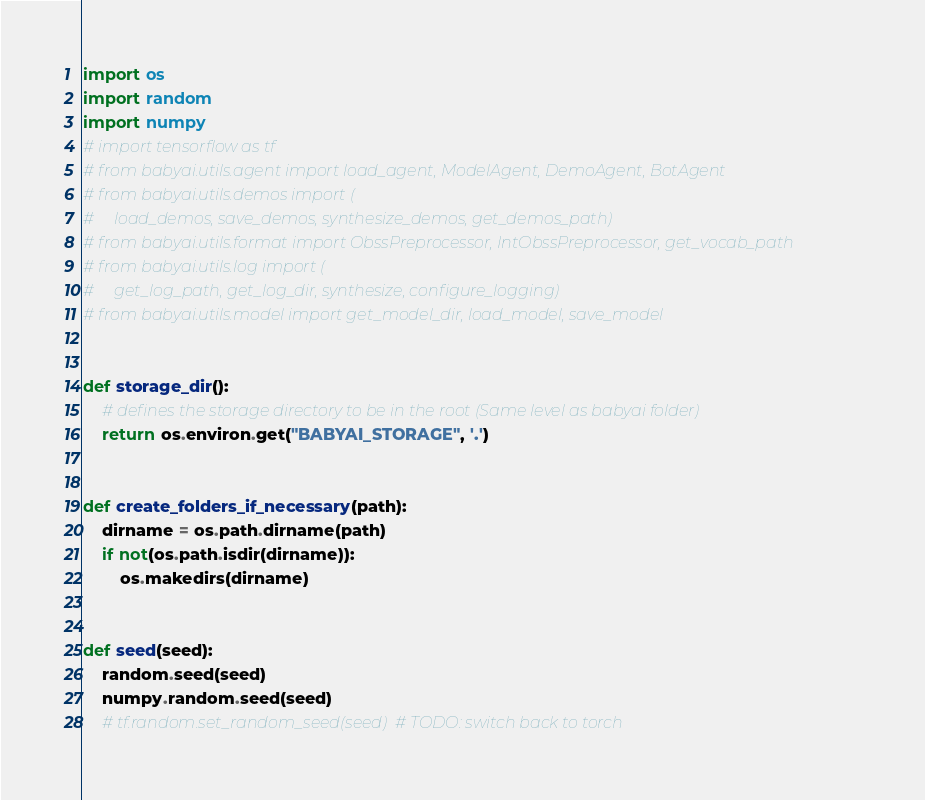<code> <loc_0><loc_0><loc_500><loc_500><_Python_>import os
import random
import numpy
# import tensorflow as tf
# from babyai.utils.agent import load_agent, ModelAgent, DemoAgent, BotAgent
# from babyai.utils.demos import (
#     load_demos, save_demos, synthesize_demos, get_demos_path)
# from babyai.utils.format import ObssPreprocessor, IntObssPreprocessor, get_vocab_path
# from babyai.utils.log import (
#     get_log_path, get_log_dir, synthesize, configure_logging)
# from babyai.utils.model import get_model_dir, load_model, save_model


def storage_dir():
    # defines the storage directory to be in the root (Same level as babyai folder)
    return os.environ.get("BABYAI_STORAGE", '.')


def create_folders_if_necessary(path):
    dirname = os.path.dirname(path)
    if not(os.path.isdir(dirname)):
        os.makedirs(dirname)


def seed(seed):
    random.seed(seed)
    numpy.random.seed(seed)
    # tf.random.set_random_seed(seed)  # TODO: switch back to torch
</code> 